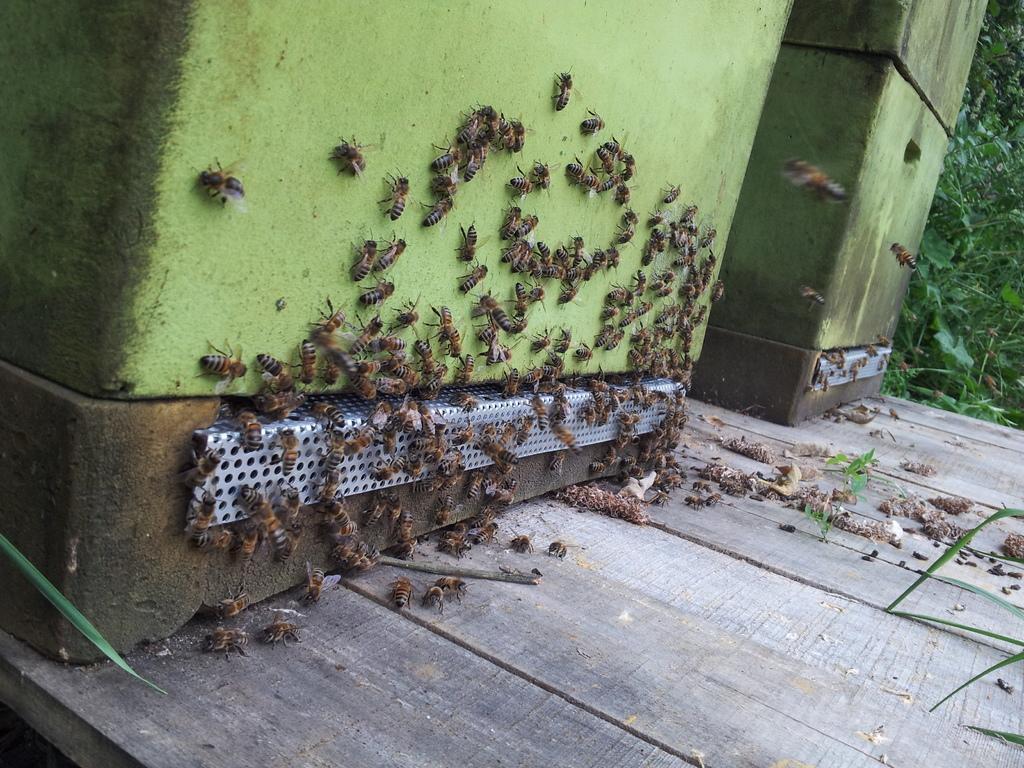Please provide a concise description of this image. In this image we can see containers, honey-bees, wooden surface and plants.   